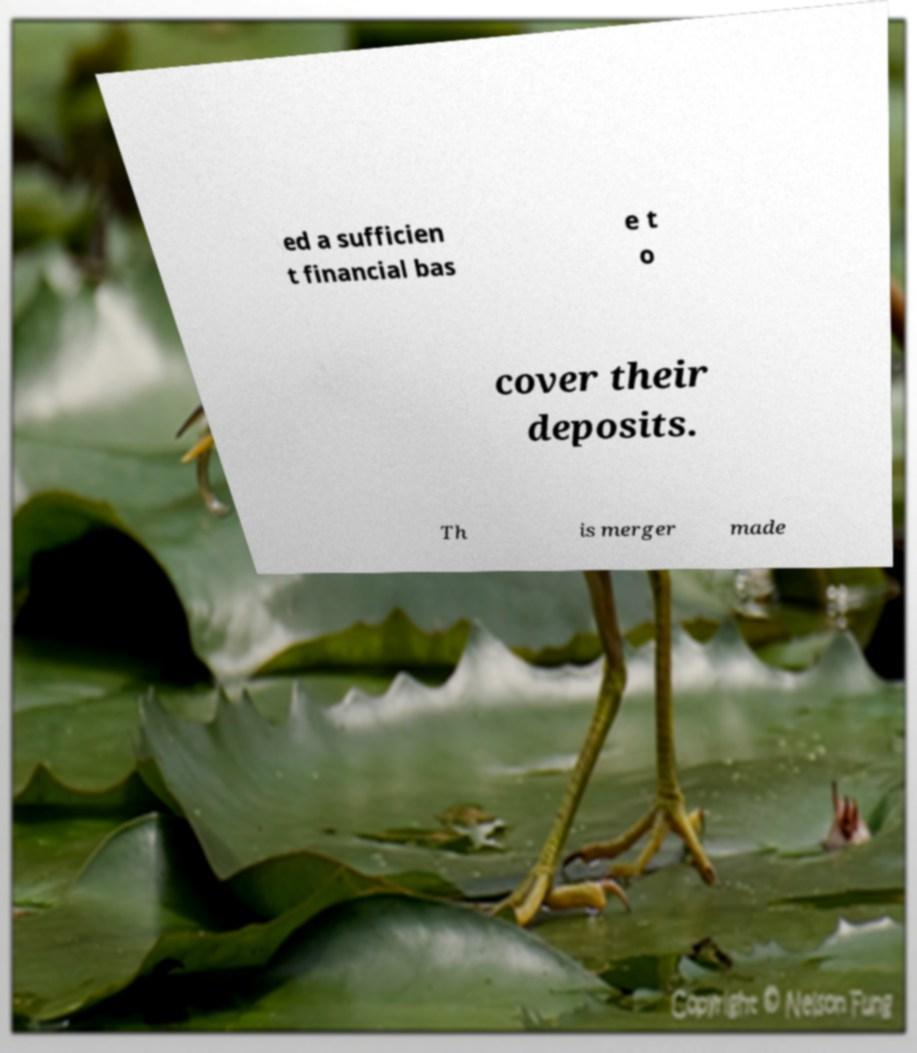What messages or text are displayed in this image? I need them in a readable, typed format. ed a sufficien t financial bas e t o cover their deposits. Th is merger made 